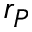<formula> <loc_0><loc_0><loc_500><loc_500>r _ { P }</formula> 